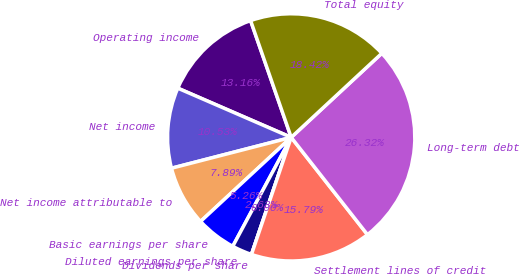<chart> <loc_0><loc_0><loc_500><loc_500><pie_chart><fcel>Operating income<fcel>Net income<fcel>Net income attributable to<fcel>Basic earnings per share<fcel>Diluted earnings per share<fcel>Dividends per share<fcel>Settlement lines of credit<fcel>Long-term debt<fcel>Total equity<nl><fcel>13.16%<fcel>10.53%<fcel>7.89%<fcel>5.26%<fcel>2.63%<fcel>0.0%<fcel>15.79%<fcel>26.32%<fcel>18.42%<nl></chart> 